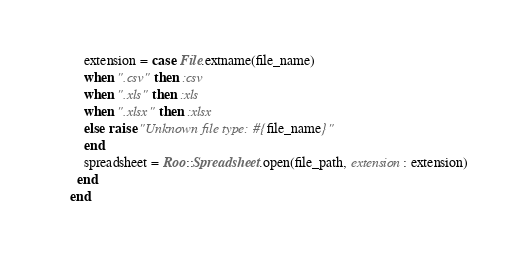Convert code to text. <code><loc_0><loc_0><loc_500><loc_500><_Ruby_>    extension = case File.extname(file_name)
    when ".csv" then :csv
    when ".xls" then :xls
    when ".xlsx" then :xlsx
    else raise "Unknown file type: #{file_name}"
    end
    spreadsheet = Roo::Spreadsheet.open(file_path, extension: extension)
  end
end
</code> 